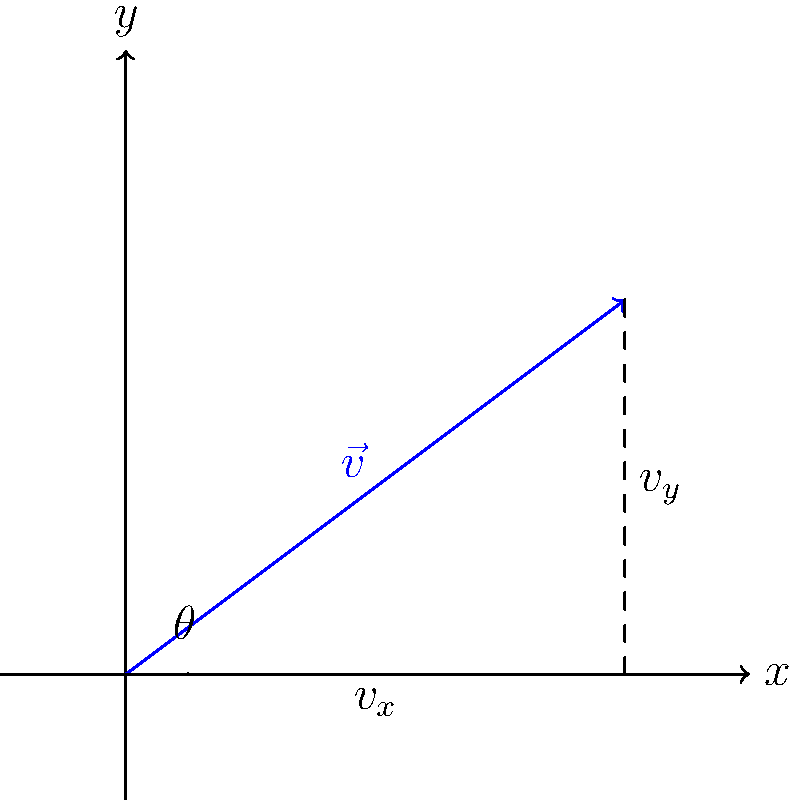As a level designer working on a projectile-based game mechanic, you need to calculate the initial horizontal and vertical components of a projectile's velocity vector. Given that the initial speed of the projectile is 50 m/s and it is launched at an angle of 37° above the horizontal, what are the horizontal ($v_x$) and vertical ($v_y$) components of the velocity vector? To solve this problem, we'll use vector decomposition and trigonometry. Here's a step-by-step approach:

1) First, recall the formulas for decomposing a vector into its x and y components:
   
   $$v_x = v \cos(\theta)$$
   $$v_y = v \sin(\theta)$$

   Where $v$ is the magnitude of the velocity vector, and $\theta$ is the angle above the horizontal.

2) We're given:
   - Initial speed (magnitude of velocity vector): $v = 50$ m/s
   - Angle above horizontal: $\theta = 37°$

3) Calculate $v_x$:
   $$v_x = 50 \cos(37°) = 50 \times 0.7986 = 39.93$$ m/s

4) Calculate $v_y$:
   $$v_y = 50 \sin(37°) = 50 \times 0.6018 = 30.09$$ m/s

5) Round the results to two decimal places for practical use in game development.

This decomposition allows for realistic trajectory calculation in the game, as the horizontal component ($v_x$) remains constant (ignoring air resistance), while the vertical component ($v_y$) is affected by gravity over time.
Answer: $v_x \approx 39.93$ m/s, $v_y \approx 30.09$ m/s 